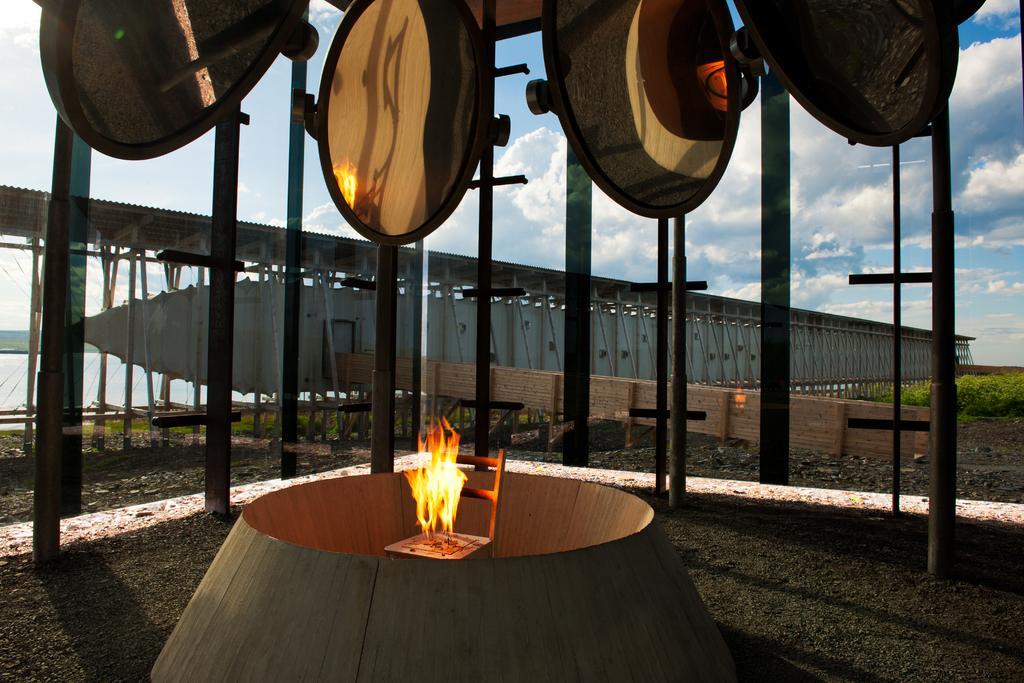Could you give a brief overview of what you see in this image? In this image, in the middle, we can see a circular object. In the object, we can see a chair. On the chair, we can see some fire. In the background, we can see some pillars, mirrors, bridge, water in a lake, trees, plants. At the top, we can see a sky, at the bottom, we can see a land with some stones. 